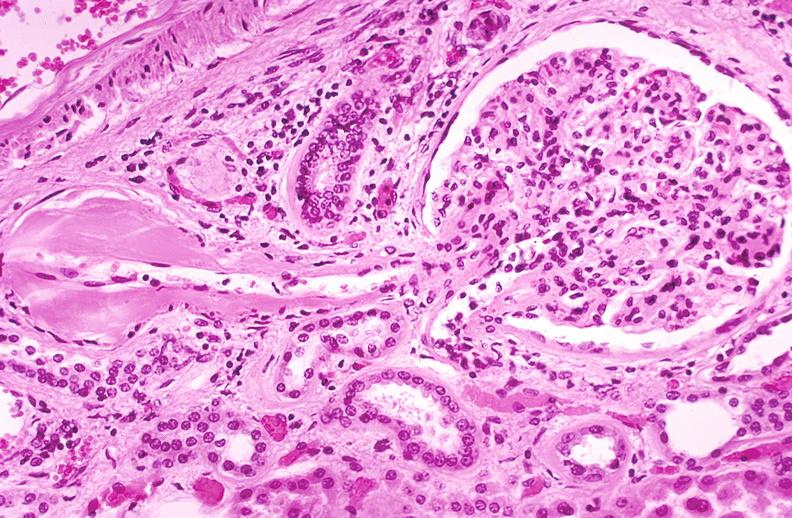where is this?
Answer the question using a single word or phrase. Urinary 